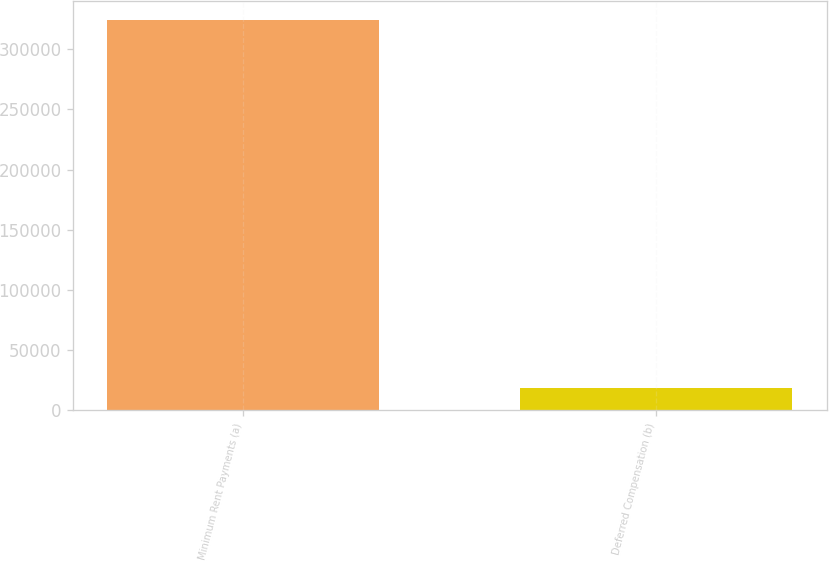Convert chart to OTSL. <chart><loc_0><loc_0><loc_500><loc_500><bar_chart><fcel>Minimum Rent Payments (a)<fcel>Deferred Compensation (b)<nl><fcel>324032<fcel>18574<nl></chart> 